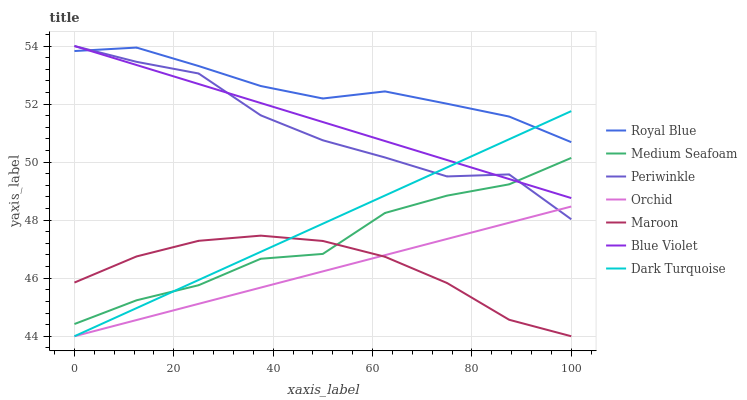Does Orchid have the minimum area under the curve?
Answer yes or no. Yes. Does Royal Blue have the maximum area under the curve?
Answer yes or no. Yes. Does Maroon have the minimum area under the curve?
Answer yes or no. No. Does Maroon have the maximum area under the curve?
Answer yes or no. No. Is Orchid the smoothest?
Answer yes or no. Yes. Is Periwinkle the roughest?
Answer yes or no. Yes. Is Maroon the smoothest?
Answer yes or no. No. Is Maroon the roughest?
Answer yes or no. No. Does Dark Turquoise have the lowest value?
Answer yes or no. Yes. Does Royal Blue have the lowest value?
Answer yes or no. No. Does Blue Violet have the highest value?
Answer yes or no. Yes. Does Royal Blue have the highest value?
Answer yes or no. No. Is Medium Seafoam less than Royal Blue?
Answer yes or no. Yes. Is Royal Blue greater than Orchid?
Answer yes or no. Yes. Does Blue Violet intersect Medium Seafoam?
Answer yes or no. Yes. Is Blue Violet less than Medium Seafoam?
Answer yes or no. No. Is Blue Violet greater than Medium Seafoam?
Answer yes or no. No. Does Medium Seafoam intersect Royal Blue?
Answer yes or no. No. 